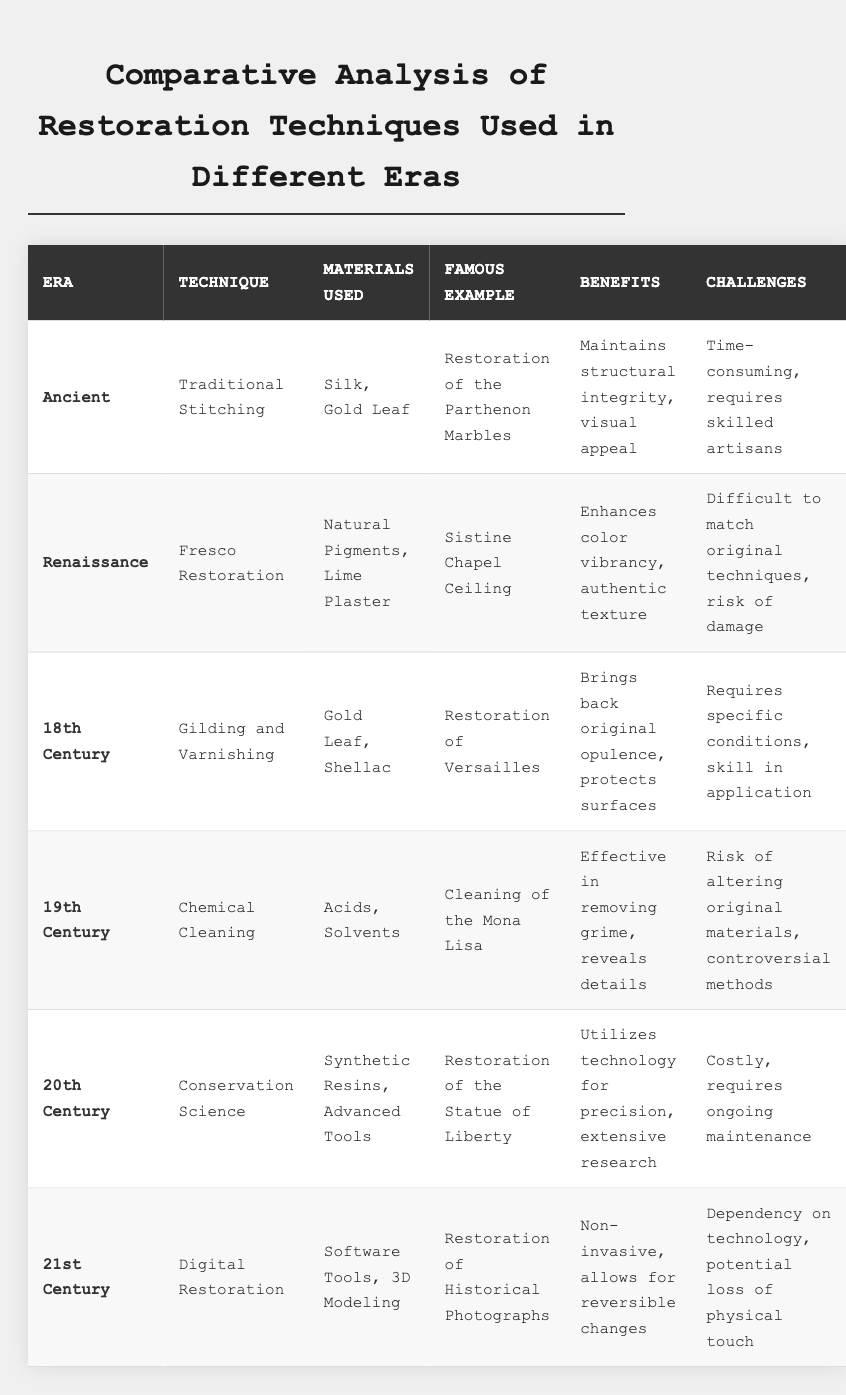What restoration technique was used for the Sistine Chapel ceiling? The table specifies that the restoration technique used for the Sistine Chapel ceiling is Fresco Restoration, which is under the Renaissance era.
Answer: Fresco Restoration Which era employed Traditional Stitching as a restoration technique? According to the table, the technique of Traditional Stitching was used in the Ancient era.
Answer: Ancient What materials were utilized in the restoration of Versailles? The table indicates that the materials used in the restoration of Versailles were Gold Leaf and Shellac, associated with the Gilding and Varnishing technique.
Answer: Gold Leaf, Shellac Is it true that the technique of Digital Restoration allows for reversible changes? The table states that one of the benefits of Digital Restoration is that it allows for reversible changes, confirming this statement is true.
Answer: True What are the benefits of using Conservation Science in restoration? The benefits listed in the table for Conservation Science include utilizing technology for precision and extensive research, thus addressing the question.
Answer: Technology for precision, extensive research Among the restoration techniques listed, which one is most associated with a risk of altering original materials? The table notes that Chemical Cleaning, used in the 19th Century, has a risk of altering original materials and is a controversial method.
Answer: Chemical Cleaning How do the challenges of Traditional Stitching compare to those of Chemical Cleaning? Traditional Stitching is noted as time-consuming and requiring skilled artisans, while Chemical Cleaning is risky regarding material alteration and is controversial. This comparison highlights that Traditional Stitching focuses on the artisan skill and time, whereas Chemical Cleaning emphasizes risks associated with the materials.
Answer: Traditional Stitching is time-consuming; Chemical Cleaning is risky Which restoration technique mentioned requires ongoing maintenance? The table specifies that the technique of Conservation Science, from the 20th Century, requires ongoing maintenance.
Answer: Conservation Science What is the benefit of using Digital Restoration? According to the table, the benefit of Digital Restoration is that it is non-invasive and allows for reversible changes.
Answer: Non-invasive, reversible changes How many different eras are represented in the restoration techniques listed? The table shows restoration techniques spanning six eras: Ancient, Renaissance, 18th Century, 19th Century, 20th Century, and 21st Century. Therefore, there are six eras represented.
Answer: Six eras What is a common challenge faced in both the Renaissance and the 19th Century restoration techniques? The Renaissance (Fresco Restoration) faces challenges in matching original techniques and risks damage, while the 19th Century (Chemical Cleaning) involves a risk of altering original materials. Both techniques highlight the complexity and risk involved in restoring historical items.
Answer: Matching original techniques and risks of damage/alters materials 